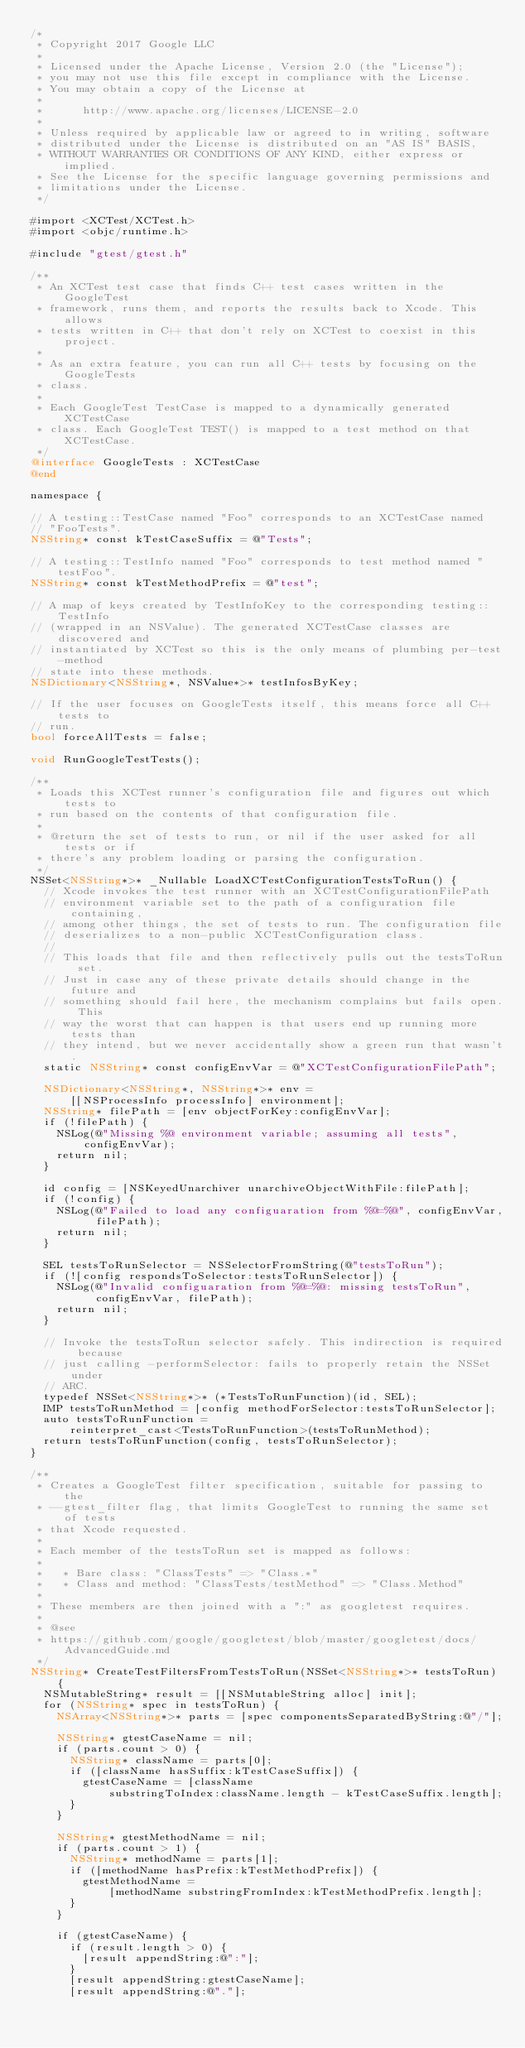Convert code to text. <code><loc_0><loc_0><loc_500><loc_500><_ObjectiveC_>/*
 * Copyright 2017 Google LLC
 *
 * Licensed under the Apache License, Version 2.0 (the "License");
 * you may not use this file except in compliance with the License.
 * You may obtain a copy of the License at
 *
 *      http://www.apache.org/licenses/LICENSE-2.0
 *
 * Unless required by applicable law or agreed to in writing, software
 * distributed under the License is distributed on an "AS IS" BASIS,
 * WITHOUT WARRANTIES OR CONDITIONS OF ANY KIND, either express or implied.
 * See the License for the specific language governing permissions and
 * limitations under the License.
 */

#import <XCTest/XCTest.h>
#import <objc/runtime.h>

#include "gtest/gtest.h"

/**
 * An XCTest test case that finds C++ test cases written in the GoogleTest
 * framework, runs them, and reports the results back to Xcode. This allows
 * tests written in C++ that don't rely on XCTest to coexist in this project.
 *
 * As an extra feature, you can run all C++ tests by focusing on the GoogleTests
 * class.
 *
 * Each GoogleTest TestCase is mapped to a dynamically generated XCTestCase
 * class. Each GoogleTest TEST() is mapped to a test method on that XCTestCase.
 */
@interface GoogleTests : XCTestCase
@end

namespace {

// A testing::TestCase named "Foo" corresponds to an XCTestCase named
// "FooTests".
NSString* const kTestCaseSuffix = @"Tests";

// A testing::TestInfo named "Foo" corresponds to test method named "testFoo".
NSString* const kTestMethodPrefix = @"test";

// A map of keys created by TestInfoKey to the corresponding testing::TestInfo
// (wrapped in an NSValue). The generated XCTestCase classes are discovered and
// instantiated by XCTest so this is the only means of plumbing per-test-method
// state into these methods.
NSDictionary<NSString*, NSValue*>* testInfosByKey;

// If the user focuses on GoogleTests itself, this means force all C++ tests to
// run.
bool forceAllTests = false;

void RunGoogleTestTests();

/**
 * Loads this XCTest runner's configuration file and figures out which tests to
 * run based on the contents of that configuration file.
 *
 * @return the set of tests to run, or nil if the user asked for all tests or if
 * there's any problem loading or parsing the configuration.
 */
NSSet<NSString*>* _Nullable LoadXCTestConfigurationTestsToRun() {
  // Xcode invokes the test runner with an XCTestConfigurationFilePath
  // environment variable set to the path of a configuration file containing,
  // among other things, the set of tests to run. The configuration file
  // deserializes to a non-public XCTestConfiguration class.
  //
  // This loads that file and then reflectively pulls out the testsToRun set.
  // Just in case any of these private details should change in the future and
  // something should fail here, the mechanism complains but fails open. This
  // way the worst that can happen is that users end up running more tests than
  // they intend, but we never accidentally show a green run that wasn't.
  static NSString* const configEnvVar = @"XCTestConfigurationFilePath";

  NSDictionary<NSString*, NSString*>* env =
      [[NSProcessInfo processInfo] environment];
  NSString* filePath = [env objectForKey:configEnvVar];
  if (!filePath) {
    NSLog(@"Missing %@ environment variable; assuming all tests", configEnvVar);
    return nil;
  }

  id config = [NSKeyedUnarchiver unarchiveObjectWithFile:filePath];
  if (!config) {
    NSLog(@"Failed to load any configuaration from %@=%@", configEnvVar,
          filePath);
    return nil;
  }

  SEL testsToRunSelector = NSSelectorFromString(@"testsToRun");
  if (![config respondsToSelector:testsToRunSelector]) {
    NSLog(@"Invalid configuaration from %@=%@: missing testsToRun",
          configEnvVar, filePath);
    return nil;
  }

  // Invoke the testsToRun selector safely. This indirection is required because
  // just calling -performSelector: fails to properly retain the NSSet under
  // ARC.
  typedef NSSet<NSString*>* (*TestsToRunFunction)(id, SEL);
  IMP testsToRunMethod = [config methodForSelector:testsToRunSelector];
  auto testsToRunFunction =
      reinterpret_cast<TestsToRunFunction>(testsToRunMethod);
  return testsToRunFunction(config, testsToRunSelector);
}

/**
 * Creates a GoogleTest filter specification, suitable for passing to the
 * --gtest_filter flag, that limits GoogleTest to running the same set of tests
 * that Xcode requested.
 *
 * Each member of the testsToRun set is mapped as follows:
 *
 *   * Bare class: "ClassTests" => "Class.*"
 *   * Class and method: "ClassTests/testMethod" => "Class.Method"
 *
 * These members are then joined with a ":" as googletest requires.
 *
 * @see
 * https://github.com/google/googletest/blob/master/googletest/docs/AdvancedGuide.md
 */
NSString* CreateTestFiltersFromTestsToRun(NSSet<NSString*>* testsToRun) {
  NSMutableString* result = [[NSMutableString alloc] init];
  for (NSString* spec in testsToRun) {
    NSArray<NSString*>* parts = [spec componentsSeparatedByString:@"/"];

    NSString* gtestCaseName = nil;
    if (parts.count > 0) {
      NSString* className = parts[0];
      if ([className hasSuffix:kTestCaseSuffix]) {
        gtestCaseName = [className
            substringToIndex:className.length - kTestCaseSuffix.length];
      }
    }

    NSString* gtestMethodName = nil;
    if (parts.count > 1) {
      NSString* methodName = parts[1];
      if ([methodName hasPrefix:kTestMethodPrefix]) {
        gtestMethodName =
            [methodName substringFromIndex:kTestMethodPrefix.length];
      }
    }

    if (gtestCaseName) {
      if (result.length > 0) {
        [result appendString:@":"];
      }
      [result appendString:gtestCaseName];
      [result appendString:@"."];</code> 